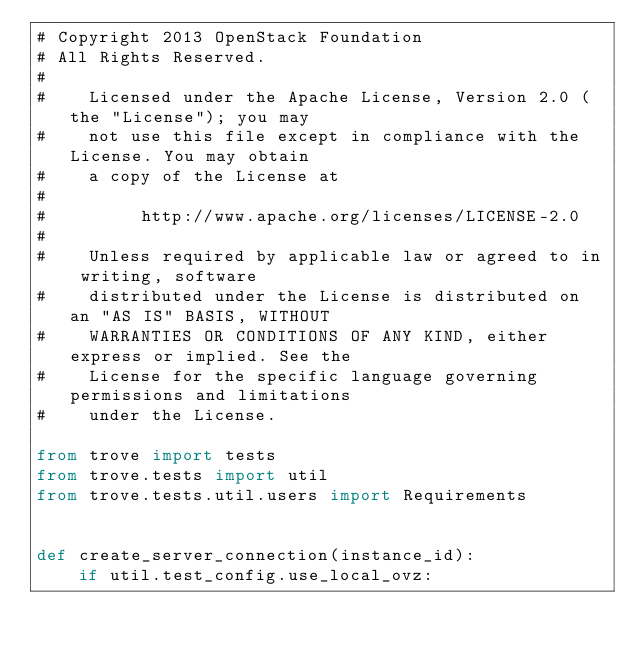Convert code to text. <code><loc_0><loc_0><loc_500><loc_500><_Python_># Copyright 2013 OpenStack Foundation
# All Rights Reserved.
#
#    Licensed under the Apache License, Version 2.0 (the "License"); you may
#    not use this file except in compliance with the License. You may obtain
#    a copy of the License at
#
#         http://www.apache.org/licenses/LICENSE-2.0
#
#    Unless required by applicable law or agreed to in writing, software
#    distributed under the License is distributed on an "AS IS" BASIS, WITHOUT
#    WARRANTIES OR CONDITIONS OF ANY KIND, either express or implied. See the
#    License for the specific language governing permissions and limitations
#    under the License.

from trove import tests
from trove.tests import util
from trove.tests.util.users import Requirements


def create_server_connection(instance_id):
    if util.test_config.use_local_ovz:</code> 